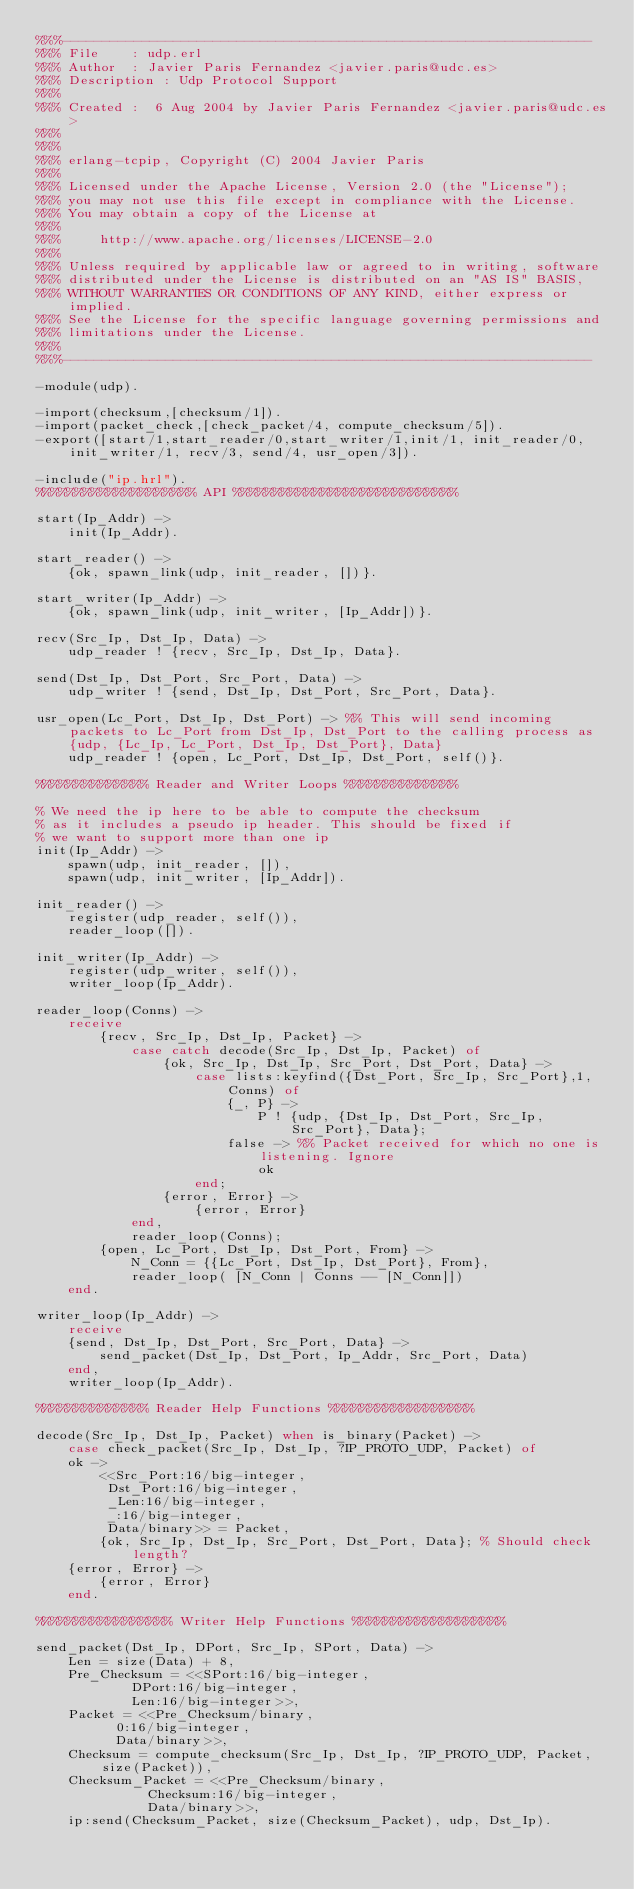Convert code to text. <code><loc_0><loc_0><loc_500><loc_500><_Erlang_>%%%-------------------------------------------------------------------
%%% File    : udp.erl
%%% Author  : Javier Paris Fernandez <javier.paris@udc.es>
%%% Description : Udp Protocol Support
%%%
%%% Created :  6 Aug 2004 by Javier Paris Fernandez <javier.paris@udc.es>
%%%
%%%
%%% erlang-tcpip, Copyright (C) 2004 Javier Paris
%%%
%%% Licensed under the Apache License, Version 2.0 (the "License");
%%% you may not use this file except in compliance with the License.
%%% You may obtain a copy of the License at
%%%
%%%     http://www.apache.org/licenses/LICENSE-2.0
%%%
%%% Unless required by applicable law or agreed to in writing, software
%%% distributed under the License is distributed on an "AS IS" BASIS,
%%% WITHOUT WARRANTIES OR CONDITIONS OF ANY KIND, either express or implied.
%%% See the License for the specific language governing permissions and
%%% limitations under the License.
%%%
%%%-------------------------------------------------------------------

-module(udp).

-import(checksum,[checksum/1]).
-import(packet_check,[check_packet/4, compute_checksum/5]).
-export([start/1,start_reader/0,start_writer/1,init/1, init_reader/0, init_writer/1, recv/3, send/4, usr_open/3]).

-include("ip.hrl").
%%%%%%%%%%%%%%%%%%%% API %%%%%%%%%%%%%%%%%%%%%%%%%%%%

start(Ip_Addr) ->
    init(Ip_Addr).

start_reader() ->
    {ok, spawn_link(udp, init_reader, [])}.

start_writer(Ip_Addr) ->
    {ok, spawn_link(udp, init_writer, [Ip_Addr])}.

recv(Src_Ip, Dst_Ip, Data) ->
    udp_reader ! {recv, Src_Ip, Dst_Ip, Data}.

send(Dst_Ip, Dst_Port, Src_Port, Data) ->
    udp_writer ! {send, Dst_Ip, Dst_Port, Src_Port, Data}.

usr_open(Lc_Port, Dst_Ip, Dst_Port) -> %% This will send incoming packets to Lc_Port from Dst_Ip, Dst_Port to the calling process as {udp, {Lc_Ip, Lc_Port, Dst_Ip, Dst_Port}, Data}
	udp_reader ! {open, Lc_Port, Dst_Ip, Dst_Port, self()}.

%%%%%%%%%%%%%% Reader and Writer Loops %%%%%%%%%%%%%%

% We need the ip here to be able to compute the checksum
% as it includes a pseudo ip header. This should be fixed if
% we want to support more than one ip
init(Ip_Addr) ->
    spawn(udp, init_reader, []),
    spawn(udp, init_writer, [Ip_Addr]).

init_reader() ->
    register(udp_reader, self()),
    reader_loop([]).

init_writer(Ip_Addr) ->
    register(udp_writer, self()),
    writer_loop(Ip_Addr).

reader_loop(Conns) ->
	receive
		{recv, Src_Ip, Dst_Ip, Packet} ->
			case catch decode(Src_Ip, Dst_Ip, Packet) of
				{ok, Src_Ip, Dst_Ip, Src_Port, Dst_Port, Data} ->
					case lists:keyfind({Dst_Port, Src_Ip, Src_Port},1,Conns) of
						{_, P} ->
							P ! {udp, {Dst_Ip, Dst_Port, Src_Ip, Src_Port}, Data};
						false -> %% Packet received for which no one is listening. Ignore
							ok
					end;
				{error, Error} ->
					{error, Error}
			end,
			reader_loop(Conns);
		{open, Lc_Port, Dst_Ip, Dst_Port, From} ->
			N_Conn = {{Lc_Port, Dst_Ip, Dst_Port}, From},
			reader_loop( [N_Conn | Conns -- [N_Conn]])
	end.

writer_loop(Ip_Addr) ->
    receive 
	{send, Dst_Ip, Dst_Port, Src_Port, Data} ->
	    send_packet(Dst_Ip, Dst_Port, Ip_Addr, Src_Port, Data)
    end,
    writer_loop(Ip_Addr).

%%%%%%%%%%%%%% Reader Help Functions %%%%%%%%%%%%%%%%%%

decode(Src_Ip, Dst_Ip, Packet) when is_binary(Packet) ->
    case check_packet(Src_Ip, Dst_Ip, ?IP_PROTO_UDP, Packet) of
	ok ->
	    <<Src_Port:16/big-integer,
	     Dst_Port:16/big-integer,
	     _Len:16/big-integer,
	     _:16/big-integer,
	     Data/binary>> = Packet,
	    {ok, Src_Ip, Dst_Ip, Src_Port, Dst_Port, Data}; % Should check length?
	{error, Error} ->
	    {error, Error}
    end.

%%%%%%%%%%%%%%%%% Writer Help Functions %%%%%%%%%%%%%%%%%%%

send_packet(Dst_Ip, DPort, Src_Ip, SPort, Data) ->
    Len = size(Data) + 8,
    Pre_Checksum = <<SPort:16/big-integer,
		    DPort:16/big-integer,
		    Len:16/big-integer>>,
    Packet = <<Pre_Checksum/binary,
	      0:16/big-integer,
	      Data/binary>>,
    Checksum = compute_checksum(Src_Ip, Dst_Ip, ?IP_PROTO_UDP, Packet, size(Packet)),
    Checksum_Packet = <<Pre_Checksum/binary, 
		      Checksum:16/big-integer, 
		      Data/binary>>,
    ip:send(Checksum_Packet, size(Checksum_Packet), udp, Dst_Ip).
</code> 